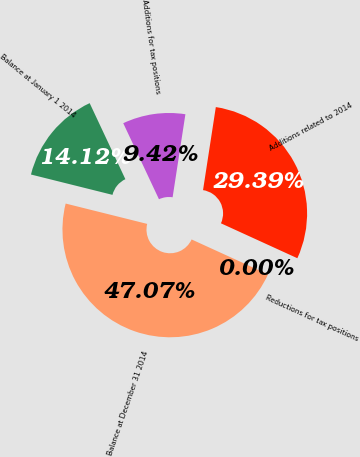Convert chart. <chart><loc_0><loc_0><loc_500><loc_500><pie_chart><fcel>Balance at January 1 2014<fcel>Additions for tax positions<fcel>Additions related to 2014<fcel>Reductions for tax positions<fcel>Balance at December 31 2014<nl><fcel>14.12%<fcel>9.42%<fcel>29.39%<fcel>0.0%<fcel>47.07%<nl></chart> 